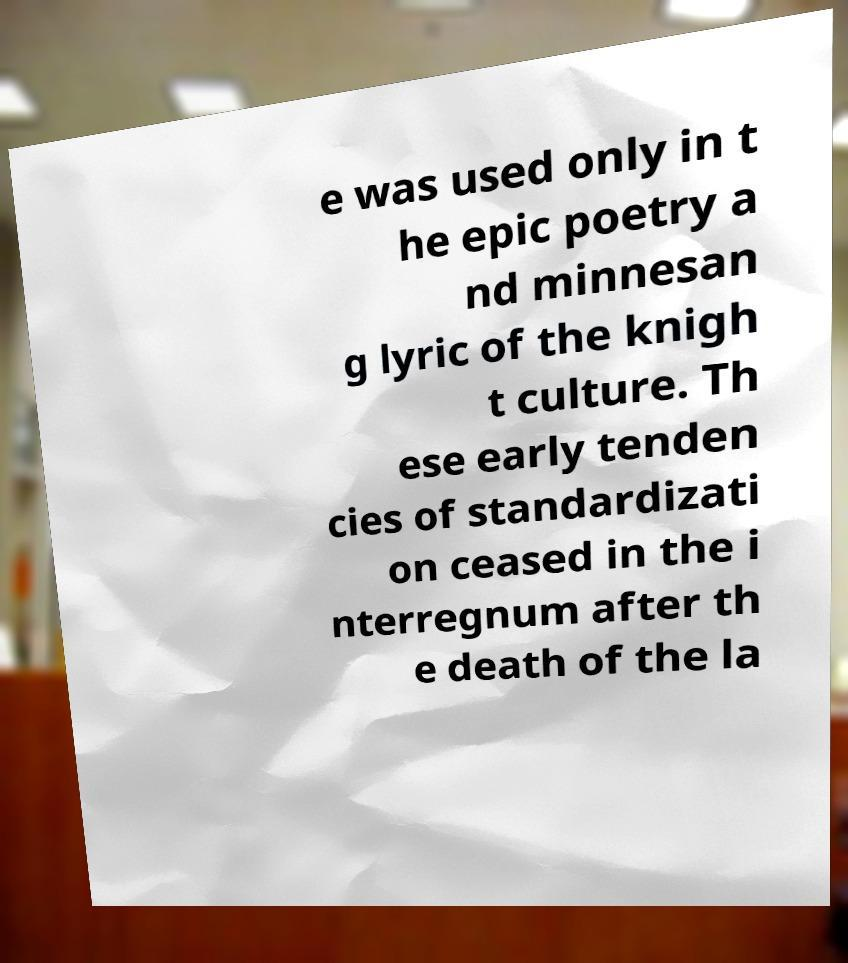Please read and relay the text visible in this image. What does it say? e was used only in t he epic poetry a nd minnesan g lyric of the knigh t culture. Th ese early tenden cies of standardizati on ceased in the i nterregnum after th e death of the la 